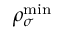<formula> <loc_0><loc_0><loc_500><loc_500>\rho _ { \sigma } ^ { \min }</formula> 